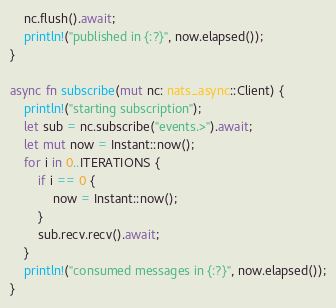<code> <loc_0><loc_0><loc_500><loc_500><_Rust_>    nc.flush().await;
    println!("published in {:?}", now.elapsed());
}

async fn subscribe(mut nc: nats_async::Client) {
    println!("starting subscription");
    let sub = nc.subscribe("events.>").await;
    let mut now = Instant::now();
    for i in 0..ITERATIONS {
        if i == 0 {
            now = Instant::now();
        }
        sub.recv.recv().await;
    }
    println!("consumed messages in {:?}", now.elapsed());
}
</code> 